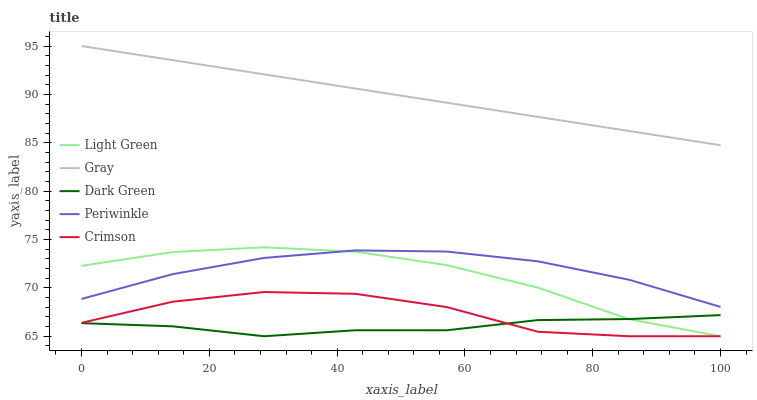Does Dark Green have the minimum area under the curve?
Answer yes or no. Yes. Does Gray have the maximum area under the curve?
Answer yes or no. Yes. Does Periwinkle have the minimum area under the curve?
Answer yes or no. No. Does Periwinkle have the maximum area under the curve?
Answer yes or no. No. Is Gray the smoothest?
Answer yes or no. Yes. Is Crimson the roughest?
Answer yes or no. Yes. Is Periwinkle the smoothest?
Answer yes or no. No. Is Periwinkle the roughest?
Answer yes or no. No. Does Crimson have the lowest value?
Answer yes or no. Yes. Does Periwinkle have the lowest value?
Answer yes or no. No. Does Gray have the highest value?
Answer yes or no. Yes. Does Periwinkle have the highest value?
Answer yes or no. No. Is Light Green less than Gray?
Answer yes or no. Yes. Is Gray greater than Periwinkle?
Answer yes or no. Yes. Does Crimson intersect Light Green?
Answer yes or no. Yes. Is Crimson less than Light Green?
Answer yes or no. No. Is Crimson greater than Light Green?
Answer yes or no. No. Does Light Green intersect Gray?
Answer yes or no. No. 